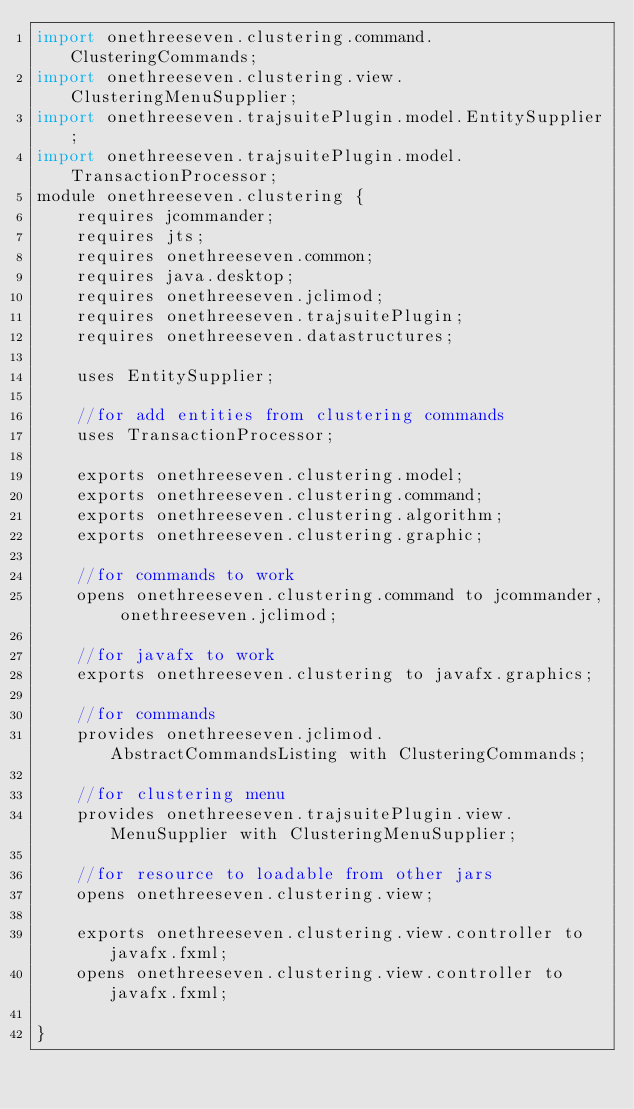Convert code to text. <code><loc_0><loc_0><loc_500><loc_500><_Java_>import onethreeseven.clustering.command.ClusteringCommands;
import onethreeseven.clustering.view.ClusteringMenuSupplier;
import onethreeseven.trajsuitePlugin.model.EntitySupplier;
import onethreeseven.trajsuitePlugin.model.TransactionProcessor;
module onethreeseven.clustering {
    requires jcommander;
    requires jts;
    requires onethreeseven.common;
    requires java.desktop;
    requires onethreeseven.jclimod;
    requires onethreeseven.trajsuitePlugin;
    requires onethreeseven.datastructures;

    uses EntitySupplier;

    //for add entities from clustering commands
    uses TransactionProcessor;

    exports onethreeseven.clustering.model;
    exports onethreeseven.clustering.command;
    exports onethreeseven.clustering.algorithm;
    exports onethreeseven.clustering.graphic;

    //for commands to work
    opens onethreeseven.clustering.command to jcommander, onethreeseven.jclimod;

    //for javafx to work
    exports onethreeseven.clustering to javafx.graphics;

    //for commands
    provides onethreeseven.jclimod.AbstractCommandsListing with ClusteringCommands;

    //for clustering menu
    provides onethreeseven.trajsuitePlugin.view.MenuSupplier with ClusteringMenuSupplier;

    //for resource to loadable from other jars
    opens onethreeseven.clustering.view;

    exports onethreeseven.clustering.view.controller to javafx.fxml;
    opens onethreeseven.clustering.view.controller to javafx.fxml;

}</code> 